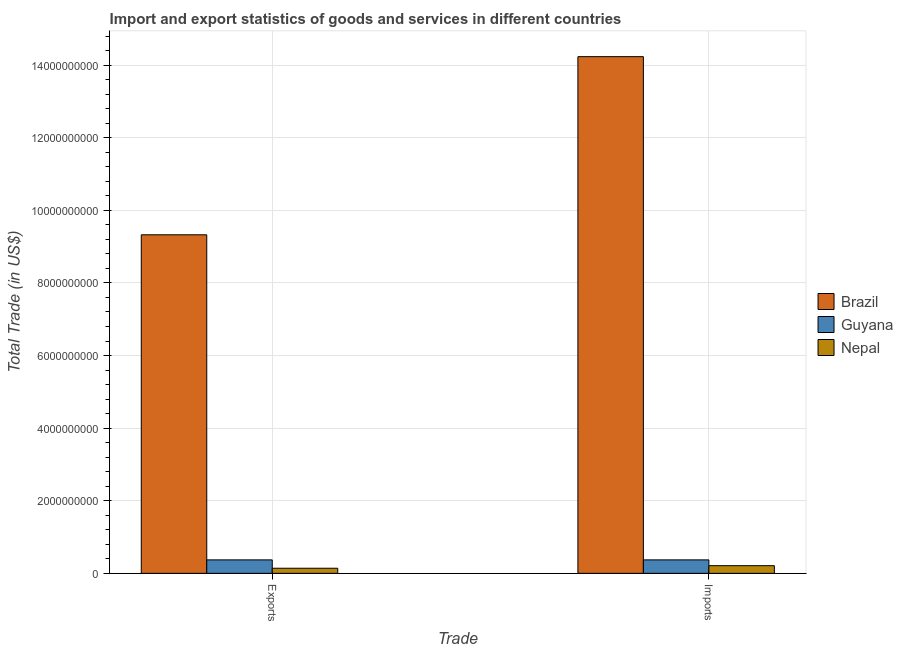How many different coloured bars are there?
Your answer should be very brief. 3. How many groups of bars are there?
Your answer should be compact. 2. Are the number of bars per tick equal to the number of legend labels?
Make the answer very short. Yes. Are the number of bars on each tick of the X-axis equal?
Your response must be concise. Yes. How many bars are there on the 2nd tick from the left?
Provide a short and direct response. 3. What is the label of the 1st group of bars from the left?
Your response must be concise. Exports. What is the imports of goods and services in Nepal?
Give a very brief answer. 2.11e+08. Across all countries, what is the maximum imports of goods and services?
Make the answer very short. 1.42e+1. Across all countries, what is the minimum export of goods and services?
Give a very brief answer. 1.40e+08. In which country was the export of goods and services maximum?
Your answer should be compact. Brazil. In which country was the imports of goods and services minimum?
Offer a terse response. Nepal. What is the total imports of goods and services in the graph?
Your answer should be very brief. 1.48e+1. What is the difference between the export of goods and services in Brazil and that in Nepal?
Offer a very short reply. 9.19e+09. What is the difference between the imports of goods and services in Nepal and the export of goods and services in Brazil?
Keep it short and to the point. -9.12e+09. What is the average export of goods and services per country?
Keep it short and to the point. 3.28e+09. What is the difference between the export of goods and services and imports of goods and services in Nepal?
Your answer should be very brief. -7.04e+07. In how many countries, is the export of goods and services greater than 6800000000 US$?
Ensure brevity in your answer.  1. What is the ratio of the export of goods and services in Guyana to that in Brazil?
Make the answer very short. 0.04. What does the 2nd bar from the left in Exports represents?
Your response must be concise. Guyana. Are all the bars in the graph horizontal?
Offer a very short reply. No. How many countries are there in the graph?
Provide a short and direct response. 3. Does the graph contain grids?
Keep it short and to the point. Yes. Where does the legend appear in the graph?
Make the answer very short. Center right. How many legend labels are there?
Offer a very short reply. 3. How are the legend labels stacked?
Provide a short and direct response. Vertical. What is the title of the graph?
Offer a very short reply. Import and export statistics of goods and services in different countries. What is the label or title of the X-axis?
Keep it short and to the point. Trade. What is the label or title of the Y-axis?
Make the answer very short. Total Trade (in US$). What is the Total Trade (in US$) in Brazil in Exports?
Offer a terse response. 9.33e+09. What is the Total Trade (in US$) in Guyana in Exports?
Your answer should be compact. 3.70e+08. What is the Total Trade (in US$) of Nepal in Exports?
Give a very brief answer. 1.40e+08. What is the Total Trade (in US$) of Brazil in Imports?
Offer a terse response. 1.42e+1. What is the Total Trade (in US$) in Guyana in Imports?
Offer a very short reply. 3.71e+08. What is the Total Trade (in US$) of Nepal in Imports?
Provide a succinct answer. 2.11e+08. Across all Trade, what is the maximum Total Trade (in US$) of Brazil?
Provide a short and direct response. 1.42e+1. Across all Trade, what is the maximum Total Trade (in US$) in Guyana?
Offer a very short reply. 3.71e+08. Across all Trade, what is the maximum Total Trade (in US$) in Nepal?
Offer a terse response. 2.11e+08. Across all Trade, what is the minimum Total Trade (in US$) of Brazil?
Offer a very short reply. 9.33e+09. Across all Trade, what is the minimum Total Trade (in US$) of Guyana?
Offer a very short reply. 3.70e+08. Across all Trade, what is the minimum Total Trade (in US$) in Nepal?
Make the answer very short. 1.40e+08. What is the total Total Trade (in US$) in Brazil in the graph?
Offer a very short reply. 2.36e+1. What is the total Total Trade (in US$) in Guyana in the graph?
Make the answer very short. 7.41e+08. What is the total Total Trade (in US$) in Nepal in the graph?
Keep it short and to the point. 3.51e+08. What is the difference between the Total Trade (in US$) of Brazil in Exports and that in Imports?
Offer a very short reply. -4.91e+09. What is the difference between the Total Trade (in US$) in Guyana in Exports and that in Imports?
Your answer should be very brief. -1.25e+05. What is the difference between the Total Trade (in US$) in Nepal in Exports and that in Imports?
Ensure brevity in your answer.  -7.04e+07. What is the difference between the Total Trade (in US$) in Brazil in Exports and the Total Trade (in US$) in Guyana in Imports?
Offer a terse response. 8.96e+09. What is the difference between the Total Trade (in US$) of Brazil in Exports and the Total Trade (in US$) of Nepal in Imports?
Make the answer very short. 9.12e+09. What is the difference between the Total Trade (in US$) in Guyana in Exports and the Total Trade (in US$) in Nepal in Imports?
Your response must be concise. 1.60e+08. What is the average Total Trade (in US$) in Brazil per Trade?
Keep it short and to the point. 1.18e+1. What is the average Total Trade (in US$) of Guyana per Trade?
Your answer should be very brief. 3.71e+08. What is the average Total Trade (in US$) of Nepal per Trade?
Ensure brevity in your answer.  1.75e+08. What is the difference between the Total Trade (in US$) of Brazil and Total Trade (in US$) of Guyana in Exports?
Your answer should be very brief. 8.96e+09. What is the difference between the Total Trade (in US$) of Brazil and Total Trade (in US$) of Nepal in Exports?
Make the answer very short. 9.19e+09. What is the difference between the Total Trade (in US$) of Guyana and Total Trade (in US$) of Nepal in Exports?
Provide a succinct answer. 2.30e+08. What is the difference between the Total Trade (in US$) in Brazil and Total Trade (in US$) in Guyana in Imports?
Your answer should be compact. 1.39e+1. What is the difference between the Total Trade (in US$) of Brazil and Total Trade (in US$) of Nepal in Imports?
Give a very brief answer. 1.40e+1. What is the difference between the Total Trade (in US$) in Guyana and Total Trade (in US$) in Nepal in Imports?
Your response must be concise. 1.60e+08. What is the ratio of the Total Trade (in US$) of Brazil in Exports to that in Imports?
Offer a very short reply. 0.66. What is the ratio of the Total Trade (in US$) in Nepal in Exports to that in Imports?
Your answer should be compact. 0.67. What is the difference between the highest and the second highest Total Trade (in US$) of Brazil?
Your answer should be compact. 4.91e+09. What is the difference between the highest and the second highest Total Trade (in US$) of Guyana?
Your answer should be compact. 1.25e+05. What is the difference between the highest and the second highest Total Trade (in US$) of Nepal?
Your response must be concise. 7.04e+07. What is the difference between the highest and the lowest Total Trade (in US$) in Brazil?
Your response must be concise. 4.91e+09. What is the difference between the highest and the lowest Total Trade (in US$) of Guyana?
Provide a short and direct response. 1.25e+05. What is the difference between the highest and the lowest Total Trade (in US$) in Nepal?
Your answer should be compact. 7.04e+07. 